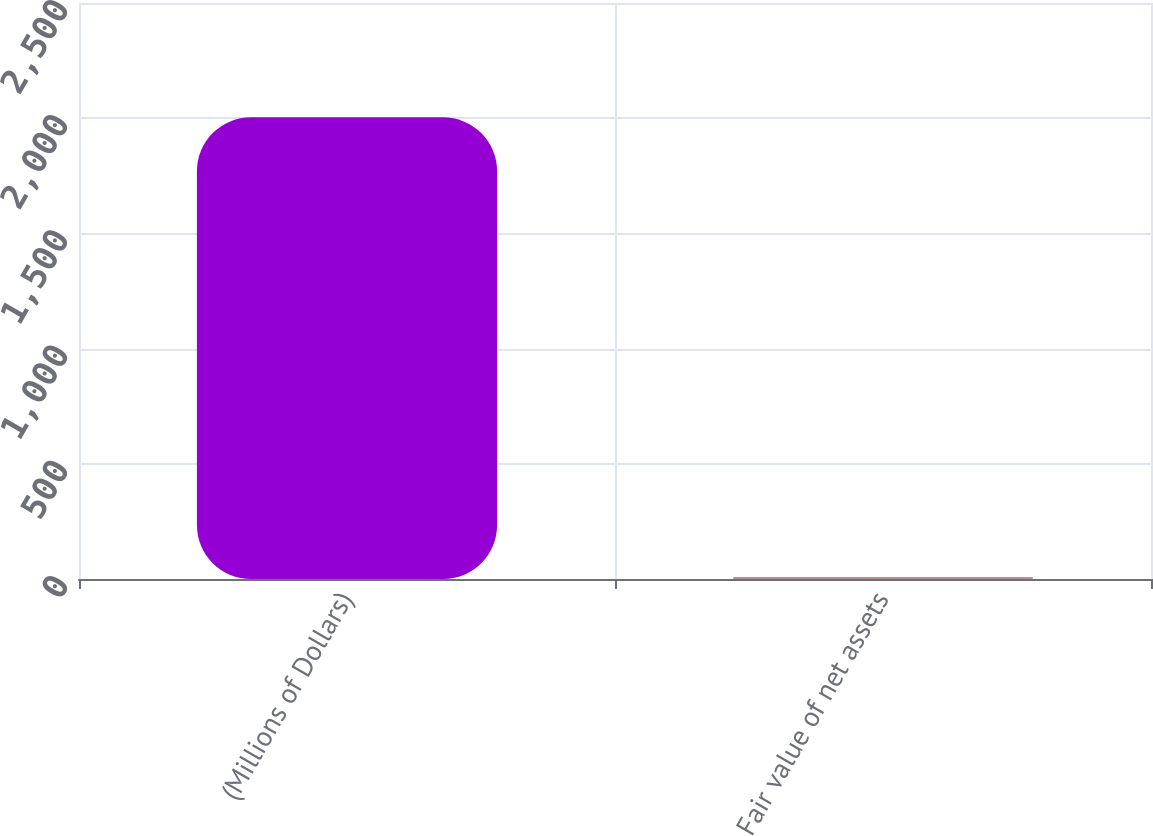Convert chart. <chart><loc_0><loc_0><loc_500><loc_500><bar_chart><fcel>(Millions of Dollars)<fcel>Fair value of net assets<nl><fcel>2004<fcel>9<nl></chart> 